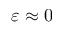<formula> <loc_0><loc_0><loc_500><loc_500>\varepsilon \approx 0</formula> 